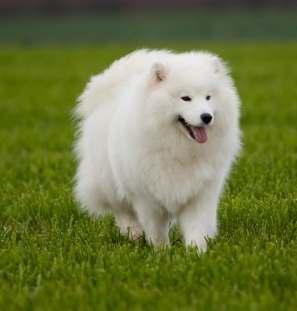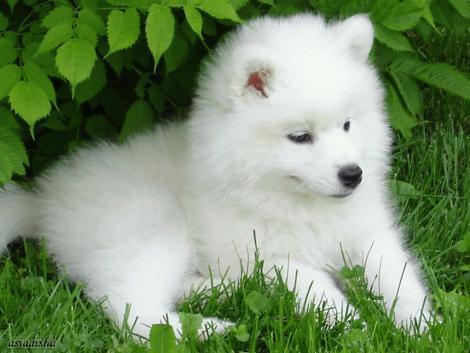The first image is the image on the left, the second image is the image on the right. Analyze the images presented: Is the assertion "There are two dogs" valid? Answer yes or no. Yes. 